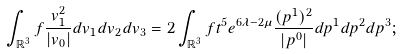Convert formula to latex. <formula><loc_0><loc_0><loc_500><loc_500>\int _ { \mathbb { R } ^ { 3 } } f \frac { v _ { 1 } ^ { 2 } } { | v _ { 0 } | } d v _ { 1 } d v _ { 2 } d v _ { 3 } = 2 \int _ { \mathbb { R } ^ { 3 } } f t ^ { 5 } e ^ { 6 \lambda - 2 \mu } \frac { ( p ^ { 1 } ) ^ { 2 } } { | p ^ { 0 } | } d p ^ { 1 } d p ^ { 2 } d p ^ { 3 } ;</formula> 